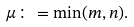Convert formula to latex. <formula><loc_0><loc_0><loc_500><loc_500>\mu \colon = \min ( m , n ) .</formula> 